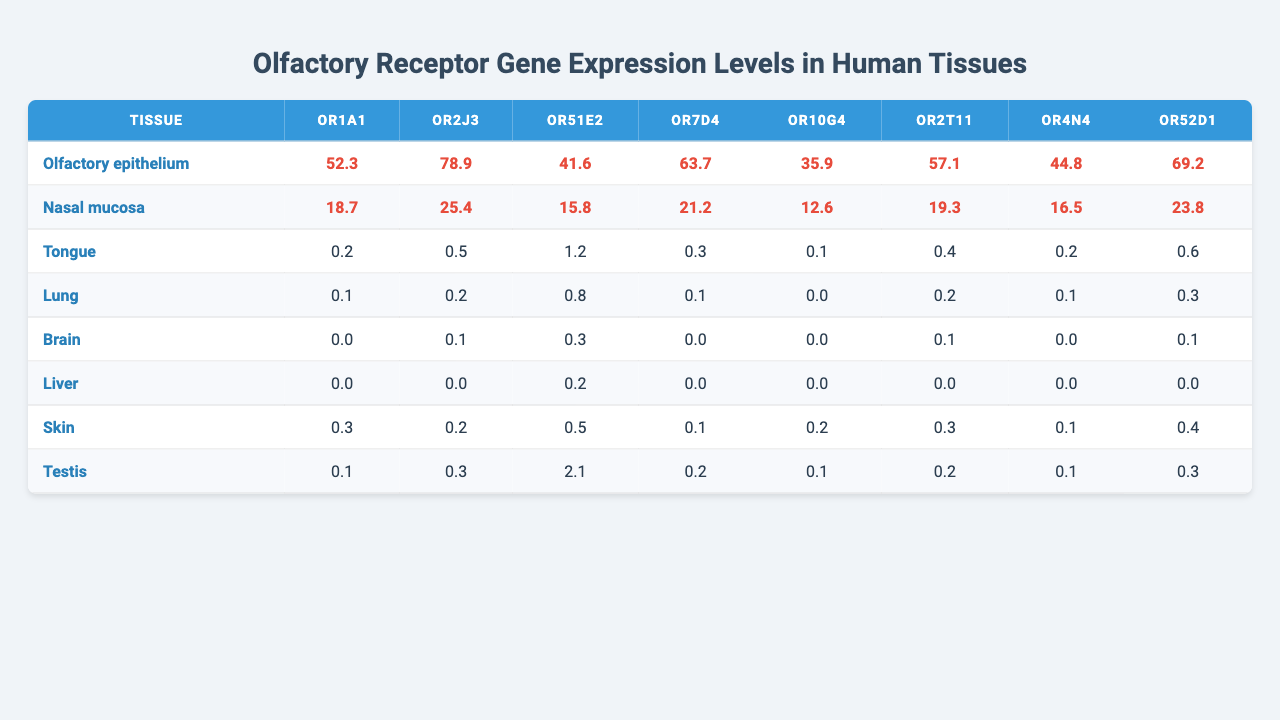What is the highest expression level for OR1A1? Looking at the column for OR1A1, the highest value is found in the Olfactory epithelium, which has a level of 52.3.
Answer: 52.3 Which tissue has the lowest expression level for OR2J3? By examining the OR2J3 column, the Tissue with the lowest expression is the Liver, which has a value of 0.0.
Answer: Liver What is the average expression level of OR51E2 across all tissues? The expression levels for OR51E2 are: 41.6, 15.8, 1.2, 0.8, 0.3, 0.2, 0.5, 2.1. Sum these values to get 62.5, and divide by 8 to find the average, which equals 7.8125.
Answer: 7.8 Is the expression level of OR10G4 in the Brain greater than that in the Lung? From the table, OR10G4 has a value of 0.0 in the Lung and 0.0 in the Brain. Since both values are equal, the statement is false.
Answer: No What tissue has the highest total expression levels when considering all olfactory receptors? First, sum the expression levels for each tissue: Olfactory epithelium (52.3+78.9+41.6+63.7+35.9+57.1+44.8+69.2), Nasal mucosa (18.7+25.4+15.8+21.2+12.6+19.3+16.5+23.8), Tongue (0.2+0.5+1.2+0.3+0.1+0.4+0.2+0.6)... After calculating the sums, the Olfactory epithelium has the highest total of 359.5.
Answer: Olfactory epithelium Which receptor has the highest expression level in the Nasal mucosa? In the Nasal mucosa column, the highest value corresponds to OR2J3, with an expression level of 25.4.
Answer: OR2J3 How many receptors have expression levels greater than 10 in the Tongue? Referencing the Tongue values, only OR2J3 (0.5) and OR51E2 (1.2) have expression levels above 0, but none exceed 10, so the total is 0.
Answer: 0 What is the difference in expression levels of OR7D4 between the Olfactory epithelium and the Brain? The values for OR7D4 are 63.7 (Olfactory epithelium) and 0.0 (Brain). The difference is calculated as 63.7 - 0.0 = 63.7.
Answer: 63.7 Which tissue shows non-zero expression for the maximum number of olfactory receptors? By reviewing the table for total non-zero values for each tissue, the Olfactory epithelium has non-zero values for all receptors (8), making it the tissue with the maximum number.
Answer: Olfactory epithelium Is it true that the expression level of OR4N4 is higher in Skin than in Brains? OR4N4 shows 0.1 in Skin and 0.0 in Brain. Since 0.1 is greater than 0.0, the statement is true.
Answer: Yes What is the total expression level of OR52D1 and OR2T11 in the Lung? In the Lung, the expression level of OR52D1 is 0.3 and OR2T11 is 0.2. Adding these levels gives 0.3 + 0.2 = 0.5.
Answer: 0.5 